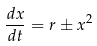Convert formula to latex. <formula><loc_0><loc_0><loc_500><loc_500>\frac { d x } { d t } = r \pm x ^ { 2 }</formula> 